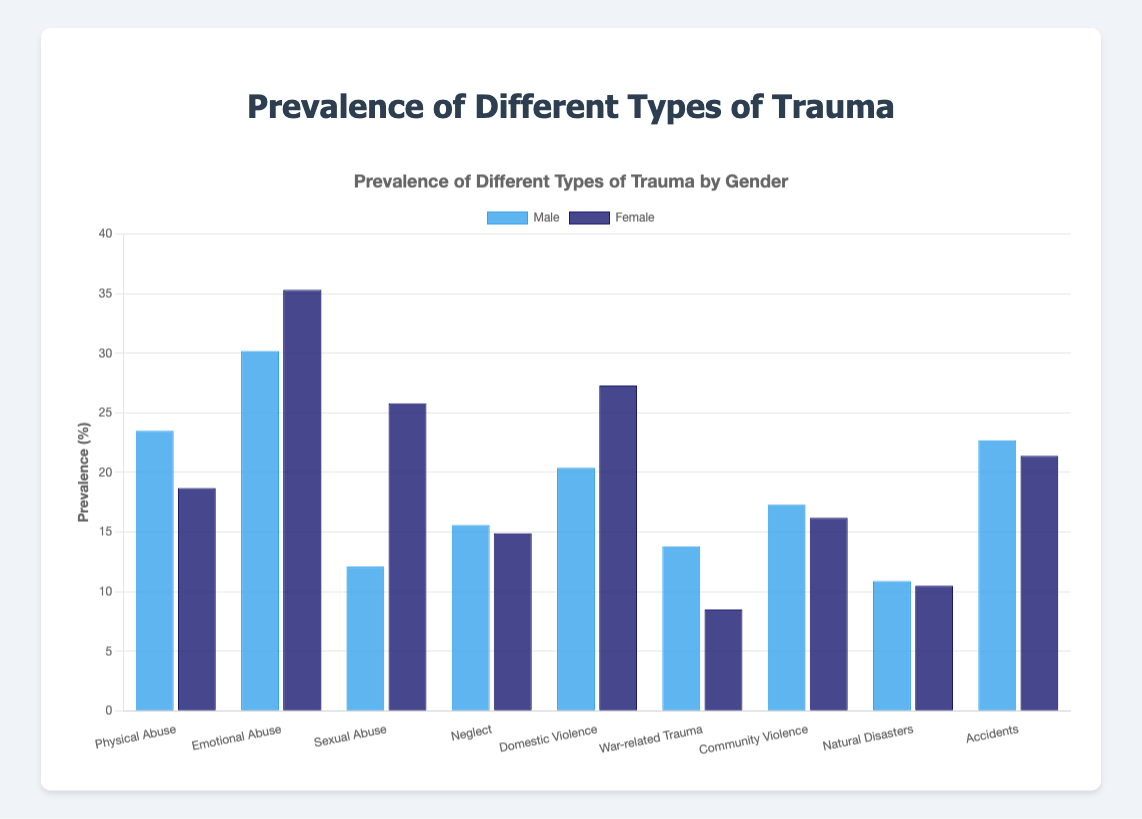What type of trauma has the highest prevalence among males? The tallest blue bar in the chart represents the highest prevalence of trauma among males. Identifying this bar, we see that "Emotional Abuse" has the highest percentage.
Answer: Emotional Abuse What is the difference in prevalence of Sexual Abuse between males and females? The blue bar (male) for Sexual Abuse is at 12.1% and the dark blue bar (female) is at 25.8%. Subtract 12.1% from 25.8% to find the difference.
Answer: 13.7% Which gender has a higher prevalence of Domestic Violence, and by how much? The dark blue bar (female) for Domestic Violence is at 27.3%, and the blue bar (male) is at 20.4%. The difference is 27.3% - 20.4%.
Answer: Female, 6.9% How does the prevalence of War-related Trauma compare between males and females? The blue bar (male) for War-related Trauma shows 13.8%, and the dark blue bar (female) shows 8.5%. Males have a higher prevalence.
Answer: Males have a higher prevalence by 5.3% What is the average prevalence of Neglect for males and females combined? Add the prevalence percentages for males (15.6%) and females (14.9%) and divide by 2. (15.6 + 14.9) / 2 = 15.25
Answer: 15.25% What is the total prevalence of traumas for females who experienced Physical Abuse, Sexual Abuse, and Neglect? Sum the prevalence percentages for females for these traumas (18.7% + 25.8% + 14.9%). 18.7 + 25.8 + 14.9 = 59.4
Answer: 59.4% Which type of trauma is more prevalent in males compared to females and also represents the largest margin? Compare differences for each trauma type where males have a higher prevalence. War-related Trauma has the largest margin (13.8% - 8.5%).
Answer: War-related Trauma What is the median prevalence of emotional trauma (i.e., Emotional Abuse) percentages for both genders? List both percentages (30.2% for males, 35.3% for females). The median of two numbers is the average of them. (30.2 + 35.3) / 2 = 32.75
Answer: 32.75 Which types of trauma show higher prevalence for females than males? Identify types where the dark blue bars (female) are taller than the blue bars (male). They include Emotional Abuse, Sexual Abuse, Domestic Violence.
Answer: Emotional Abuse, Sexual Abuse, Domestic Violence 